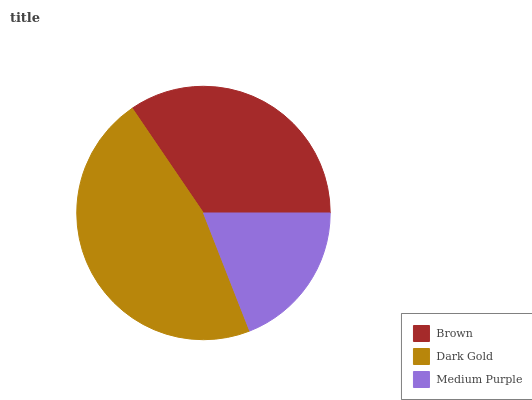Is Medium Purple the minimum?
Answer yes or no. Yes. Is Dark Gold the maximum?
Answer yes or no. Yes. Is Dark Gold the minimum?
Answer yes or no. No. Is Medium Purple the maximum?
Answer yes or no. No. Is Dark Gold greater than Medium Purple?
Answer yes or no. Yes. Is Medium Purple less than Dark Gold?
Answer yes or no. Yes. Is Medium Purple greater than Dark Gold?
Answer yes or no. No. Is Dark Gold less than Medium Purple?
Answer yes or no. No. Is Brown the high median?
Answer yes or no. Yes. Is Brown the low median?
Answer yes or no. Yes. Is Medium Purple the high median?
Answer yes or no. No. Is Medium Purple the low median?
Answer yes or no. No. 